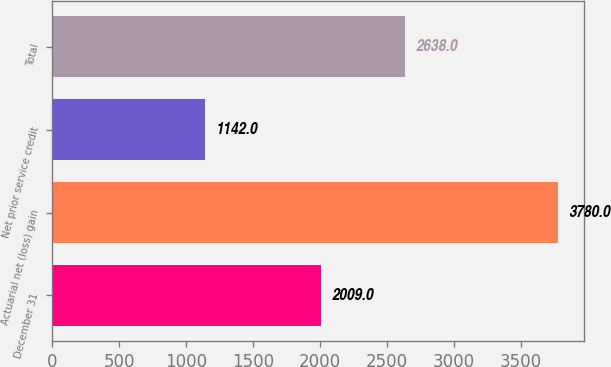Convert chart to OTSL. <chart><loc_0><loc_0><loc_500><loc_500><bar_chart><fcel>December 31<fcel>Actuarial net (loss) gain<fcel>Net prior service credit<fcel>Total<nl><fcel>2009<fcel>3780<fcel>1142<fcel>2638<nl></chart> 